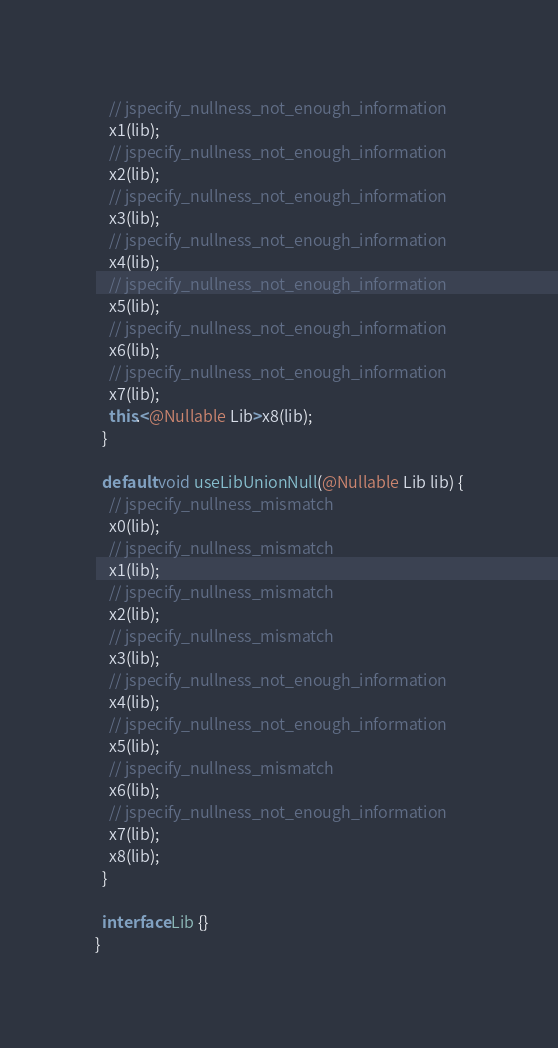Convert code to text. <code><loc_0><loc_0><loc_500><loc_500><_Java_>    // jspecify_nullness_not_enough_information
    x1(lib);
    // jspecify_nullness_not_enough_information
    x2(lib);
    // jspecify_nullness_not_enough_information
    x3(lib);
    // jspecify_nullness_not_enough_information
    x4(lib);
    // jspecify_nullness_not_enough_information
    x5(lib);
    // jspecify_nullness_not_enough_information
    x6(lib);
    // jspecify_nullness_not_enough_information
    x7(lib);
    this.<@Nullable Lib>x8(lib);
  }

  default void useLibUnionNull(@Nullable Lib lib) {
    // jspecify_nullness_mismatch
    x0(lib);
    // jspecify_nullness_mismatch
    x1(lib);
    // jspecify_nullness_mismatch
    x2(lib);
    // jspecify_nullness_mismatch
    x3(lib);
    // jspecify_nullness_not_enough_information
    x4(lib);
    // jspecify_nullness_not_enough_information
    x5(lib);
    // jspecify_nullness_mismatch
    x6(lib);
    // jspecify_nullness_not_enough_information
    x7(lib);
    x8(lib);
  }

  interface Lib {}
}
</code> 